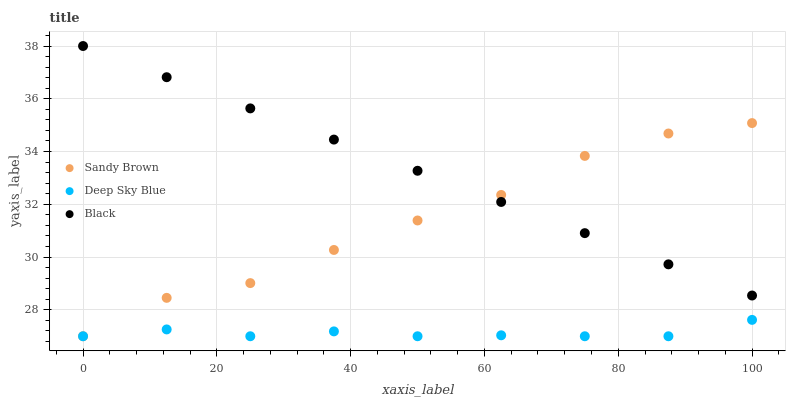Does Deep Sky Blue have the minimum area under the curve?
Answer yes or no. Yes. Does Black have the maximum area under the curve?
Answer yes or no. Yes. Does Sandy Brown have the minimum area under the curve?
Answer yes or no. No. Does Sandy Brown have the maximum area under the curve?
Answer yes or no. No. Is Black the smoothest?
Answer yes or no. Yes. Is Sandy Brown the roughest?
Answer yes or no. Yes. Is Deep Sky Blue the smoothest?
Answer yes or no. No. Is Deep Sky Blue the roughest?
Answer yes or no. No. Does Sandy Brown have the lowest value?
Answer yes or no. Yes. Does Black have the highest value?
Answer yes or no. Yes. Does Sandy Brown have the highest value?
Answer yes or no. No. Is Deep Sky Blue less than Black?
Answer yes or no. Yes. Is Black greater than Deep Sky Blue?
Answer yes or no. Yes. Does Sandy Brown intersect Black?
Answer yes or no. Yes. Is Sandy Brown less than Black?
Answer yes or no. No. Is Sandy Brown greater than Black?
Answer yes or no. No. Does Deep Sky Blue intersect Black?
Answer yes or no. No. 